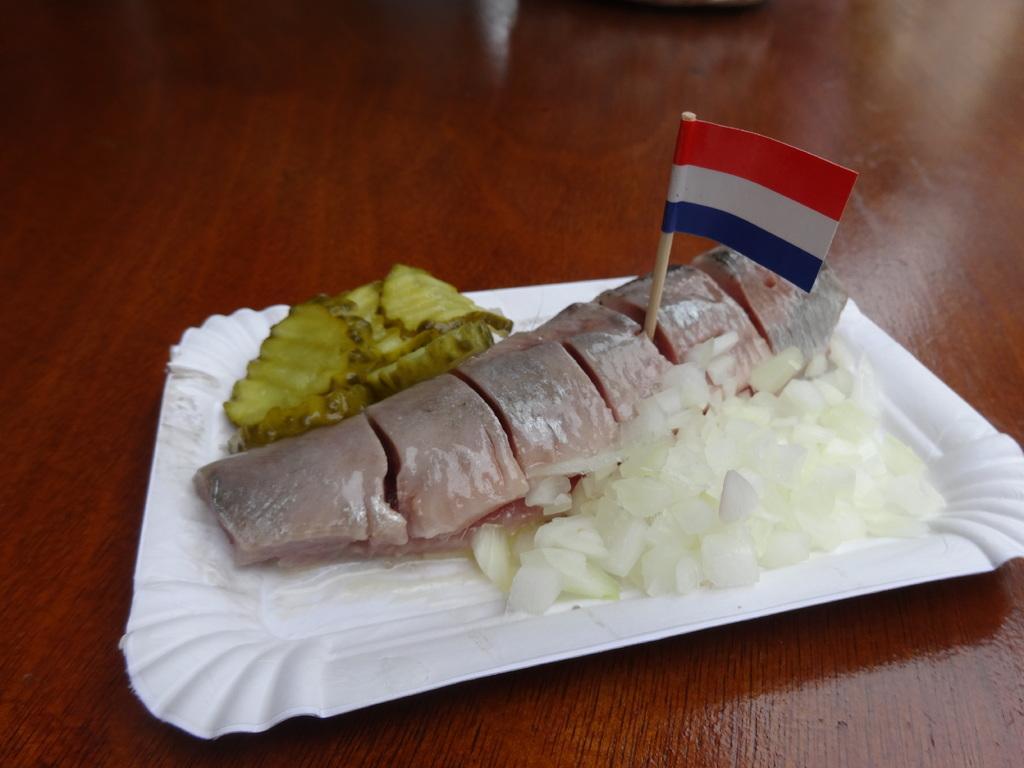How would you summarize this image in a sentence or two? In this image there is food on the plate, there is a flag, the plate is on the wooden surface, there is a wooden surface truncated. 